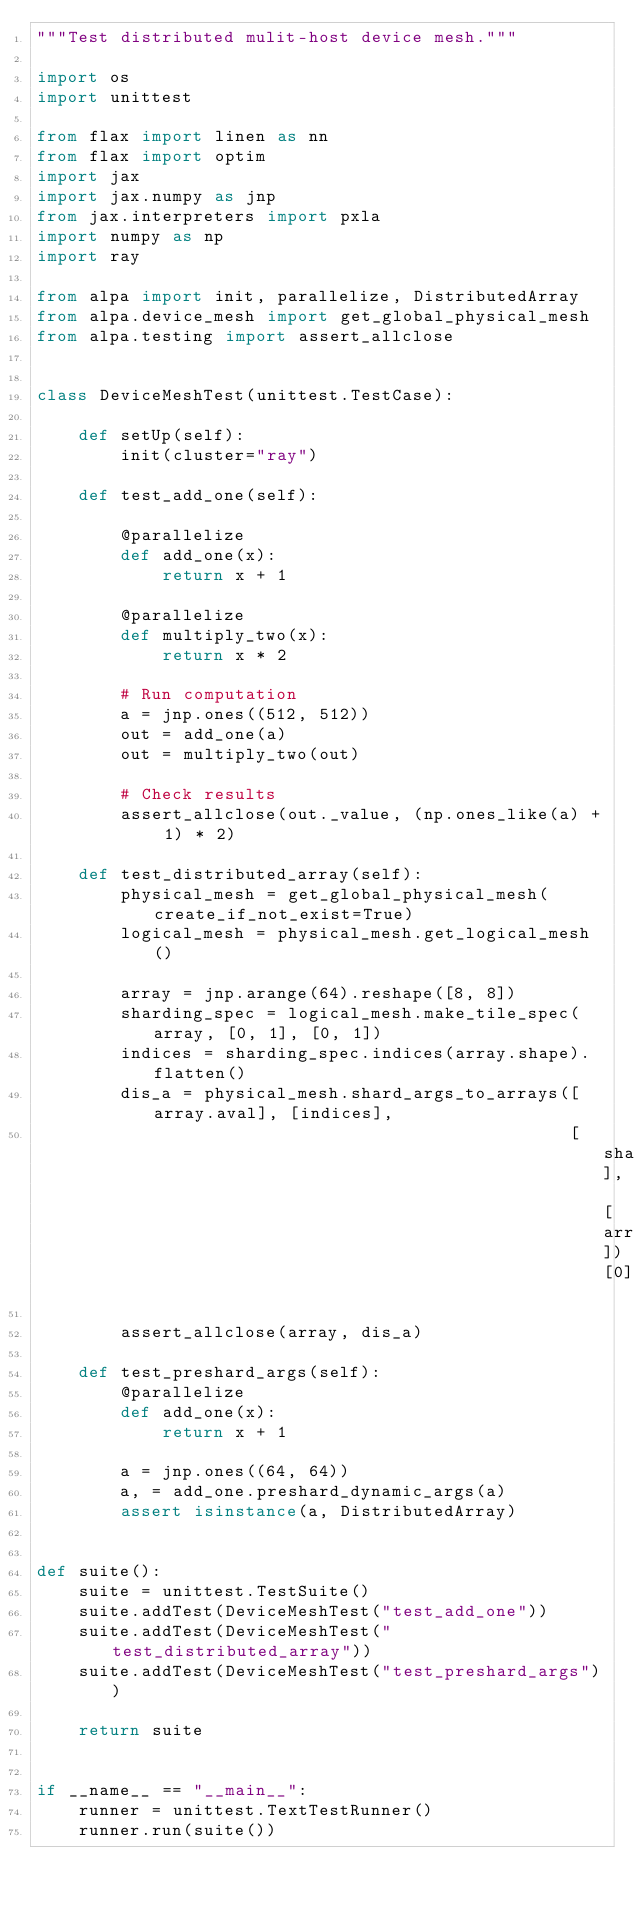<code> <loc_0><loc_0><loc_500><loc_500><_Python_>"""Test distributed mulit-host device mesh."""

import os
import unittest

from flax import linen as nn
from flax import optim
import jax
import jax.numpy as jnp
from jax.interpreters import pxla
import numpy as np
import ray

from alpa import init, parallelize, DistributedArray
from alpa.device_mesh import get_global_physical_mesh
from alpa.testing import assert_allclose


class DeviceMeshTest(unittest.TestCase):

    def setUp(self):
        init(cluster="ray")

    def test_add_one(self):

        @parallelize
        def add_one(x):
            return x + 1

        @parallelize
        def multiply_two(x):
            return x * 2

        # Run computation
        a = jnp.ones((512, 512))
        out = add_one(a)
        out = multiply_two(out)

        # Check results
        assert_allclose(out._value, (np.ones_like(a) + 1) * 2)

    def test_distributed_array(self):
        physical_mesh = get_global_physical_mesh(create_if_not_exist=True)
        logical_mesh = physical_mesh.get_logical_mesh()

        array = jnp.arange(64).reshape([8, 8])
        sharding_spec = logical_mesh.make_tile_spec(array, [0, 1], [0, 1])
        indices = sharding_spec.indices(array.shape).flatten()
        dis_a = physical_mesh.shard_args_to_arrays([array.aval], [indices],
                                                   [sharding_spec], [array])[0]

        assert_allclose(array, dis_a)

    def test_preshard_args(self):
        @parallelize
        def add_one(x):
            return x + 1

        a = jnp.ones((64, 64))
        a, = add_one.preshard_dynamic_args(a)
        assert isinstance(a, DistributedArray)


def suite():
    suite = unittest.TestSuite()
    suite.addTest(DeviceMeshTest("test_add_one"))
    suite.addTest(DeviceMeshTest("test_distributed_array"))
    suite.addTest(DeviceMeshTest("test_preshard_args"))

    return suite


if __name__ == "__main__":
    runner = unittest.TextTestRunner()
    runner.run(suite())
</code> 